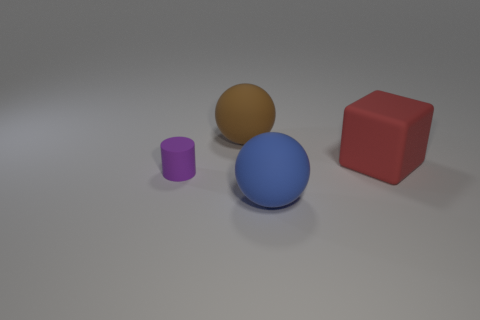Do the small purple thing and the large brown object have the same material?
Your answer should be compact. Yes. There is a thing left of the big rubber ball that is behind the tiny purple matte cylinder; are there any large matte spheres that are on the left side of it?
Your response must be concise. No. Do the large block and the small thing have the same color?
Provide a succinct answer. No. Do the big sphere in front of the big red thing and the ball that is behind the tiny object have the same material?
Provide a succinct answer. Yes. There is a large rubber thing right of the large blue matte object; what number of big matte objects are in front of it?
Your answer should be compact. 1. There is a thing that is in front of the big red rubber thing and behind the blue sphere; what size is it?
Your answer should be very brief. Small. Does the big blue sphere have the same material as the big cube behind the matte cylinder?
Give a very brief answer. Yes. Are there fewer big balls to the left of the blue object than large brown spheres right of the big red rubber cube?
Keep it short and to the point. No. What material is the big thing in front of the small object?
Offer a terse response. Rubber. What is the color of the object that is in front of the red rubber thing and behind the large blue sphere?
Keep it short and to the point. Purple. 